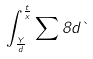Convert formula to latex. <formula><loc_0><loc_0><loc_500><loc_500>\int _ { \frac { Y } { d } } ^ { \frac { t } { x } } \sum { 8 } d \theta</formula> 